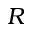<formula> <loc_0><loc_0><loc_500><loc_500>R</formula> 